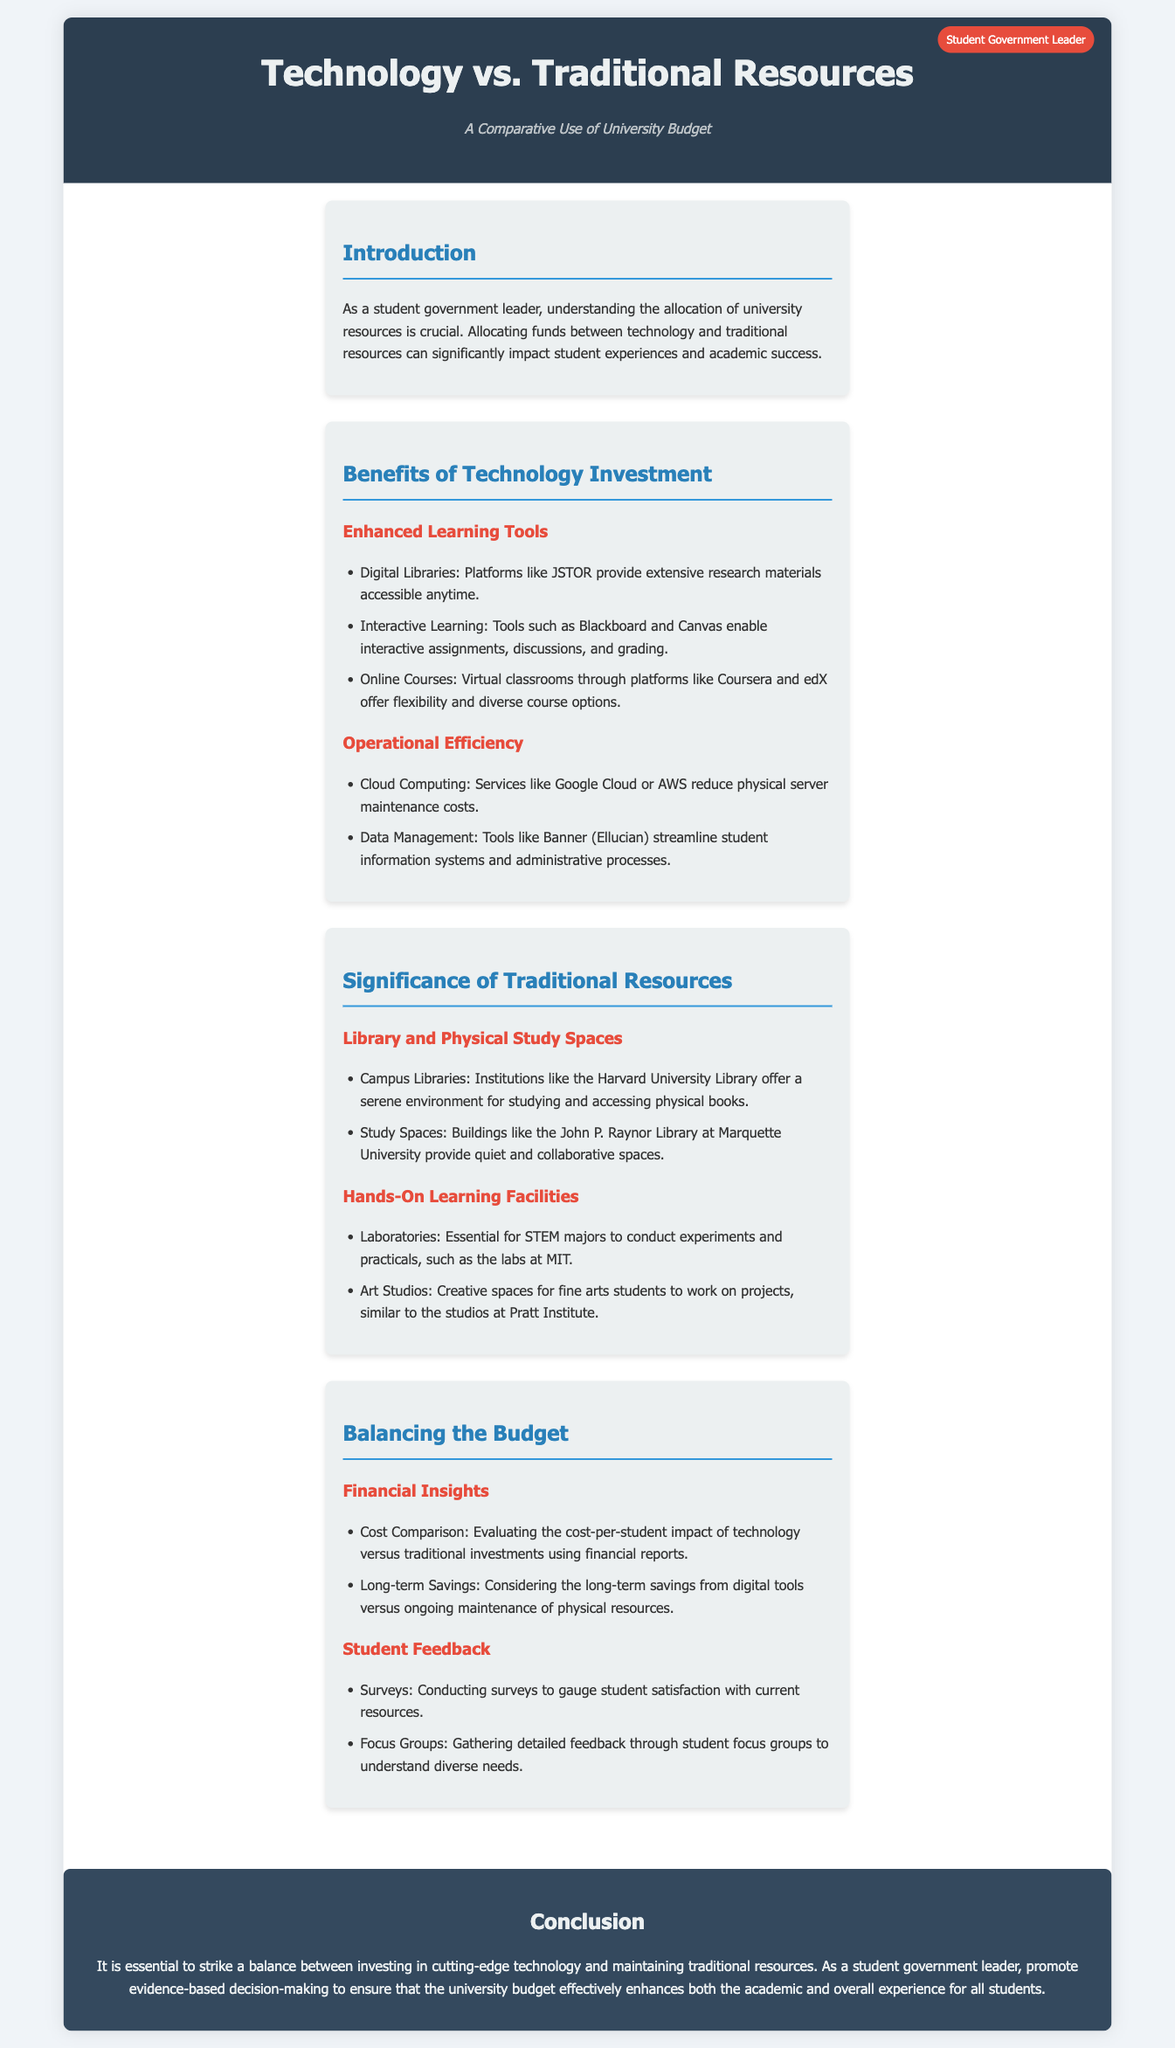What are the main categories in the university budget allocation? The main categories mentioned in the document are "Technology Investment" and "Traditional Resources."
Answer: Technology Investment, Traditional Resources What tool is mentioned for online courses? The document lists Coursera and edX as platforms for virtual classrooms.
Answer: Coursera, edX Which library is noted for its study environment? Harvard University Library is specifically mentioned for providing a serene environment for studying.
Answer: Harvard University Library What kind of feedback methods are suggested for understanding student needs? Surveys and focus groups are highlighted as methods to gather student feedback.
Answer: Surveys, Focus Groups What is highlighted as a benefit of cloud computing? The document states that cloud computing reduces physical server maintenance costs as an operational efficiency benefit.
Answer: Reduces physical server maintenance costs What is a key consideration for balancing the budget? The long-term savings from digital tools versus maintenance costs of physical resources is a significant consideration.
Answer: Long-term savings Which facility type is essential for STEM majors? Laboratories are highlighted as essential facilities for STEM majors to conduct experiments.
Answer: Laboratories What is the overarching theme of the document? The document emphasizes the need to balance investment in technology and traditional resources to enhance student experiences.
Answer: Balance investment What is the conclusion about resource allocation? The conclusion stresses the importance of evidence-based decision-making in budget allocation.
Answer: Evidence-based decision-making 